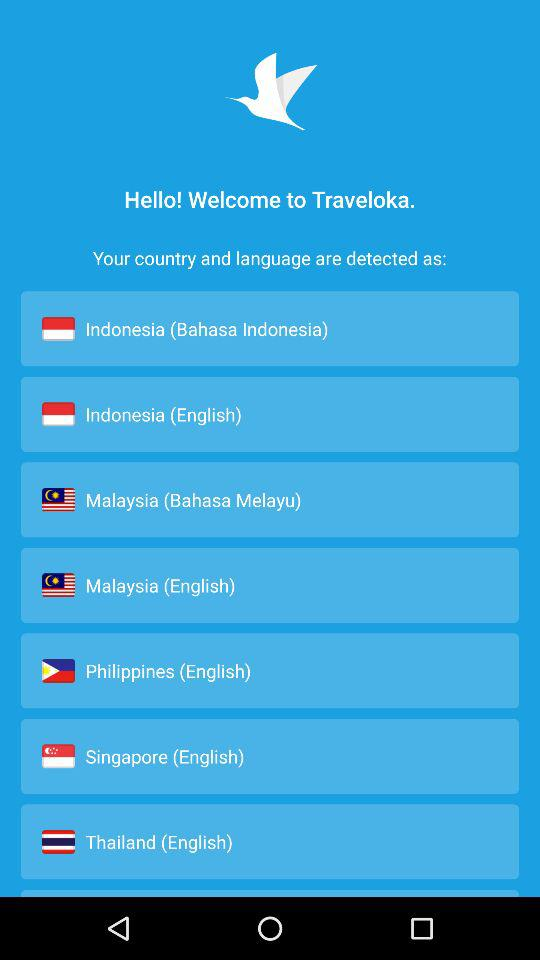Which language is used in Indonesia? The languages are Bahasa Indonesia and English. 